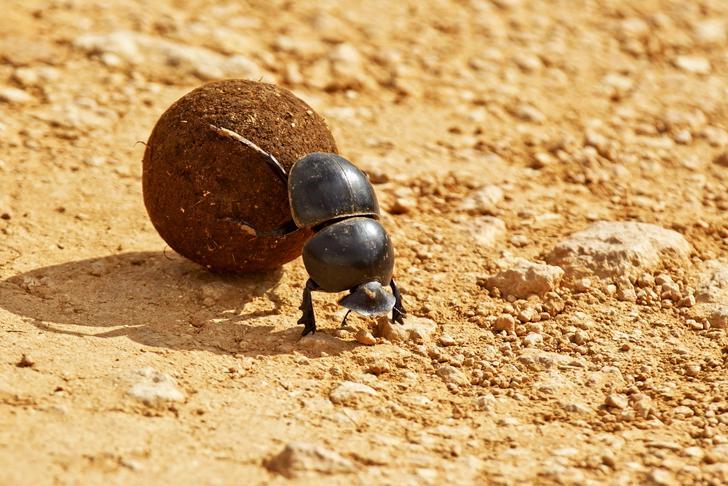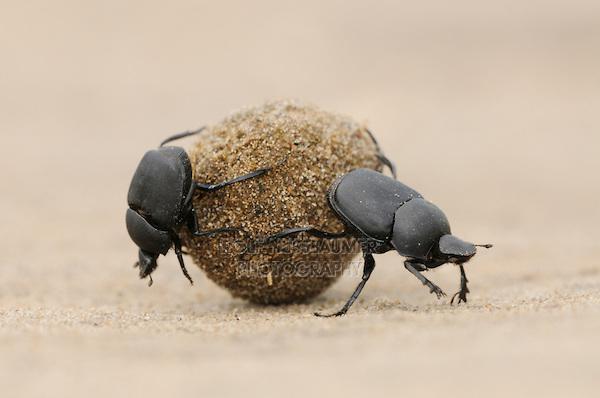The first image is the image on the left, the second image is the image on the right. Assess this claim about the two images: "There are only two beetles touching a dungball in the right image". Correct or not? Answer yes or no. Yes. The first image is the image on the left, the second image is the image on the right. Examine the images to the left and right. Is the description "An image shows beetles on the left and right of one dungball, and each beetle is in contact with the ball." accurate? Answer yes or no. Yes. 